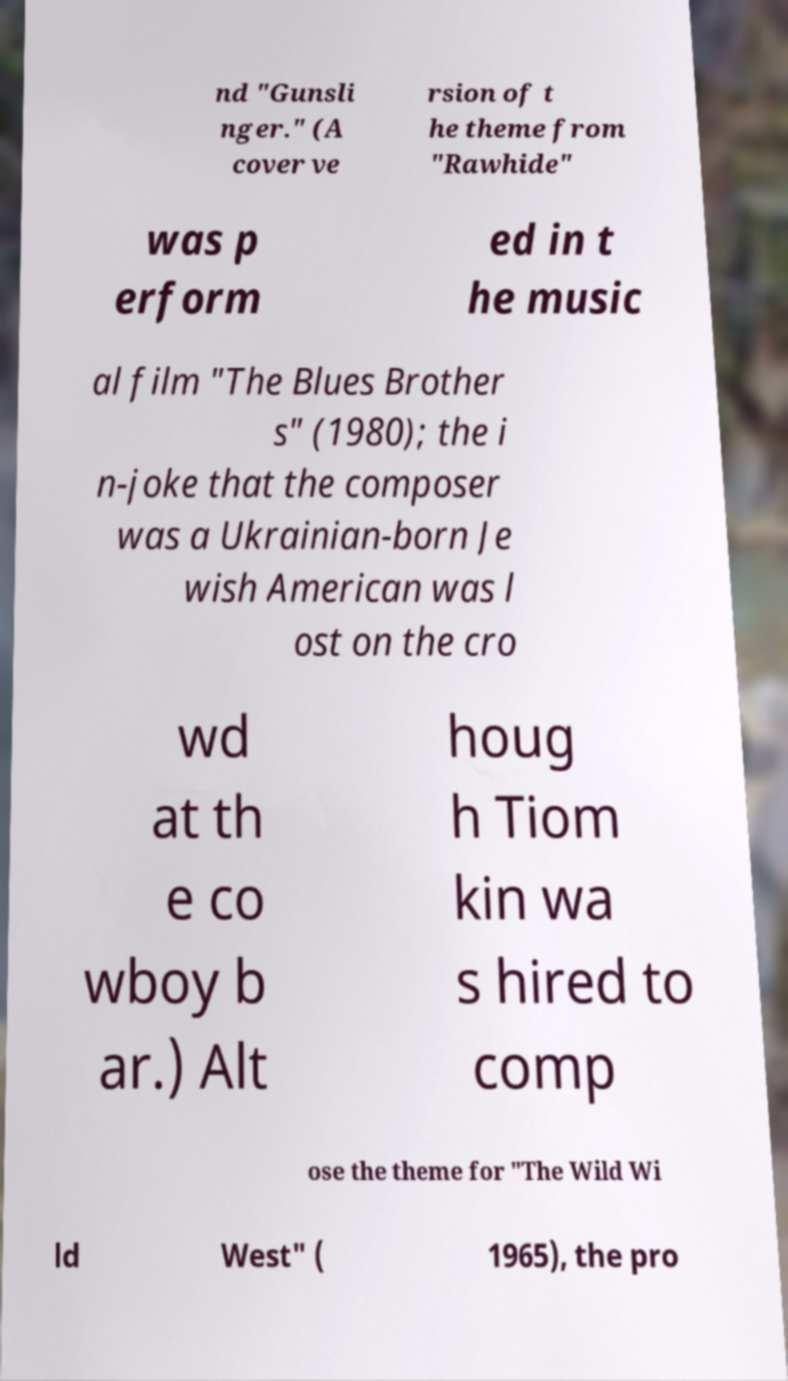For documentation purposes, I need the text within this image transcribed. Could you provide that? nd "Gunsli nger." (A cover ve rsion of t he theme from "Rawhide" was p erform ed in t he music al film "The Blues Brother s" (1980); the i n-joke that the composer was a Ukrainian-born Je wish American was l ost on the cro wd at th e co wboy b ar.) Alt houg h Tiom kin wa s hired to comp ose the theme for "The Wild Wi ld West" ( 1965), the pro 